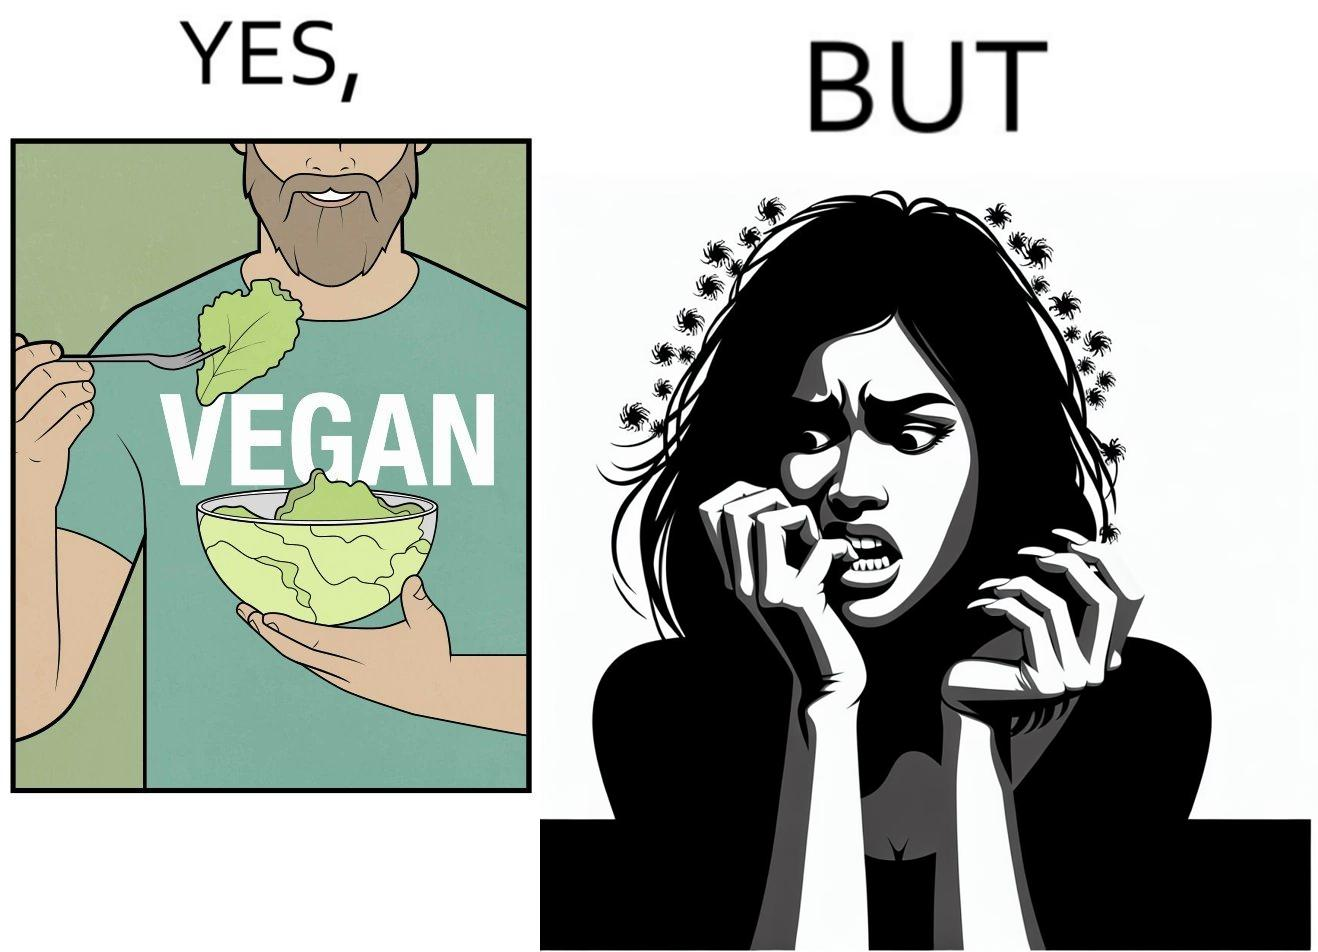What makes this image funny or satirical? The image is funny because while the man claims to be vegan, he is biting skin off his own hand. 